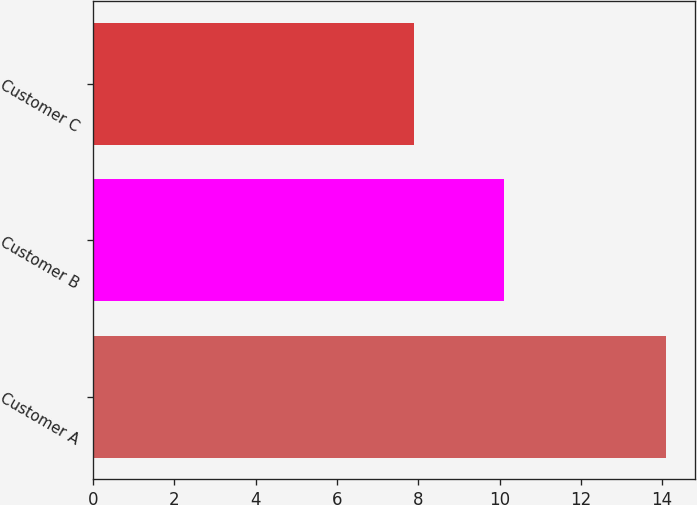<chart> <loc_0><loc_0><loc_500><loc_500><bar_chart><fcel>Customer A<fcel>Customer B<fcel>Customer C<nl><fcel>14.1<fcel>10.1<fcel>7.9<nl></chart> 